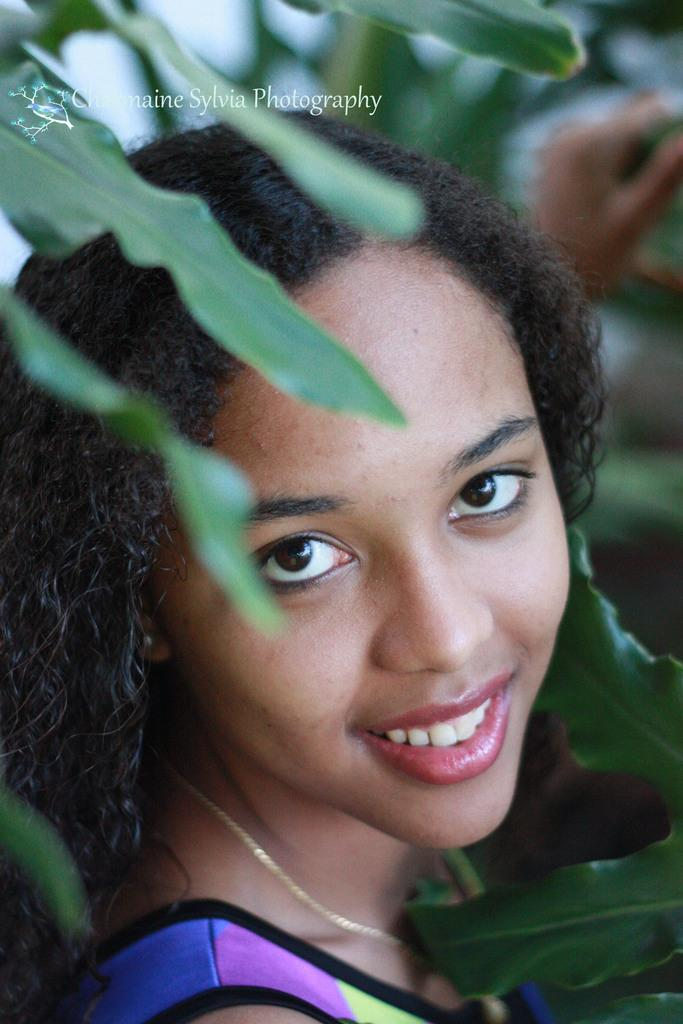Who is the main subject in the image? There is a girl in the image. What is the girl wearing? The girl is wearing a yellow, blue, and purple T-shirt. What is the girl's expression in the image? The girl is smiling. What can be seen in the background of the image? There are trees in the background of the image. How is the background of the image depicted? The background is blurred. What type of ship can be seen sailing in the background of the image? There is no ship present in the image; it features a girl with a blurred background of trees. 